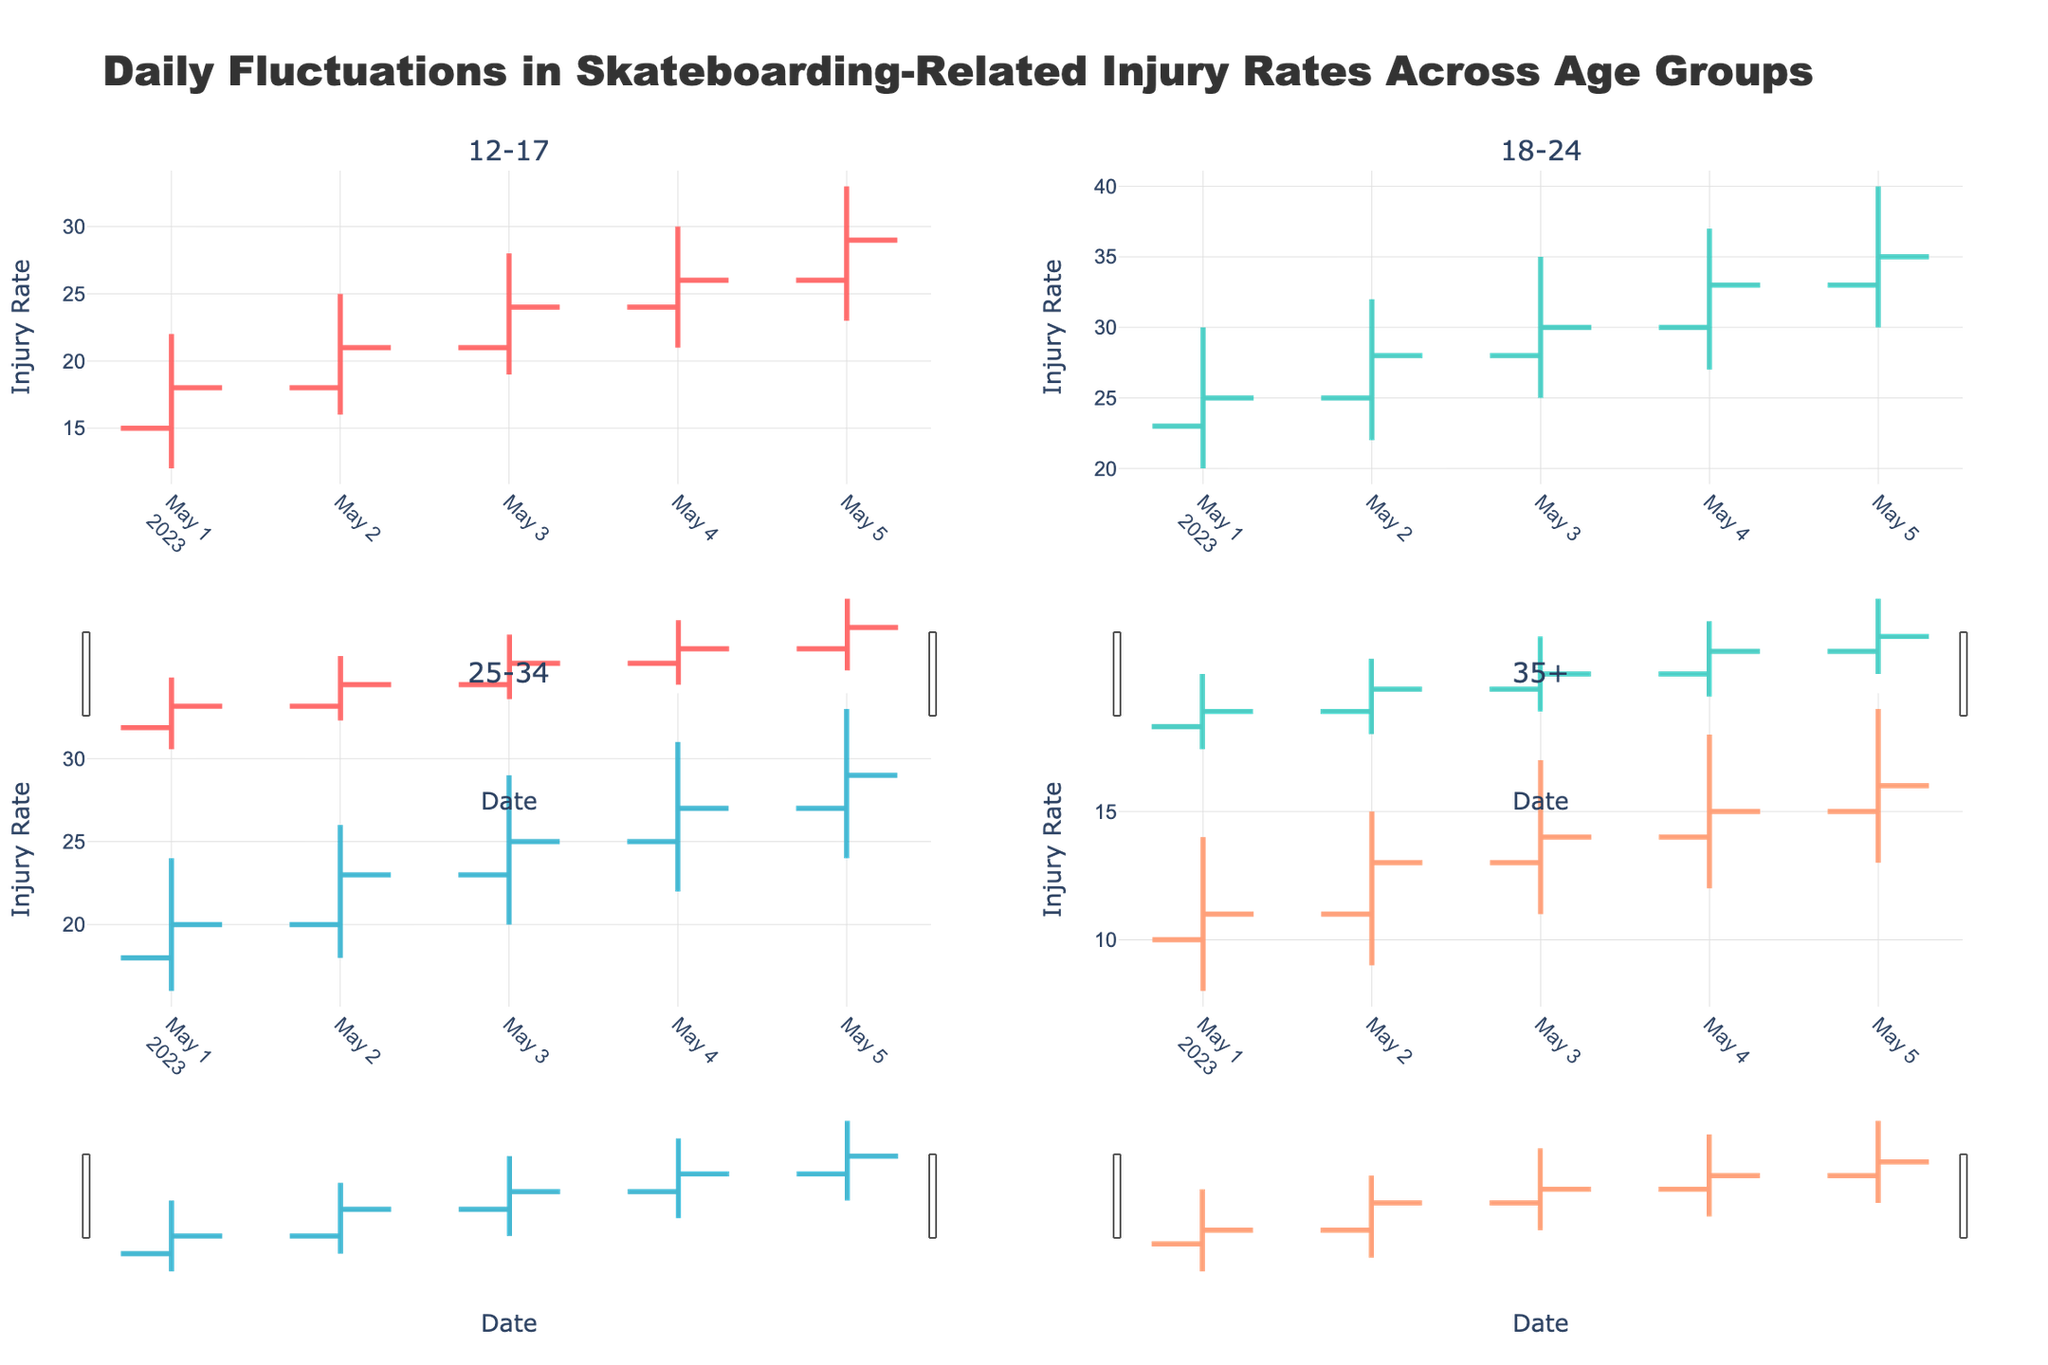what is the title of the figure? The title of the figure is often located at the top of the plot. Here it explicitly states: "Daily Fluctuations in Skateboarding-Related Injury Rates Across Age Groups".
Answer: Daily Fluctuations in Skateboarding-Related Injury Rates Across Age Groups Which age group had the highest injury rate on May 3rd? To determine this, look at the 'High' values for each age group on May 3rd. The age group 18-24 has the highest of 35.
Answer: 18-24 What was the lowest injury rate for the age group 35+ on May 4th? Check the 'Low' column in the data for the age group 35+ on May 4th. The lowest value is 12.
Answer: 12 How did the injury rate for the age group 12-17 change from May 1st to May 5th? Compare the 'Close' values of the group from May 1st to May 5th. On May 1st, it was 18, and on May 5th, it was 29.
Answer: Increased On which day did the age group 25-34 experience the highest 'High' value, and what was that value? Look at the 'High' column for the age group 25-34. The highest 'High' value is 33 on May 5th.
Answer: May 5th, 33 How much did the injury rate for the age group 18-24 increase from May 1st to May 2nd based on 'Close' values? Subtract the 'Close' value of May 1st from the value of May 2nd for the age group 18-24: 28 - 25 = 3.
Answer: 3 Compare the 'Close' values on May 4th for the age groups 12-17 and 25-34. Which one is higher, and by how much? Compare the 'Close' values of both groups on May 4th. For the age group 12-17, it's 26, and for 25-34, it's 27. The difference is 27 - 26 = 1.
Answer: 25-34, by 1 What is the difference between the highest 'High' and the lowest 'Low' for the age group 18-24 across all days? Subtract the minimum 'Low' value from the maximum 'High' value for the age group 18-24. The highest 'High' is 40, and the lowest 'Low' is 20, so the difference is 40 - 20 = 20.
Answer: 20 